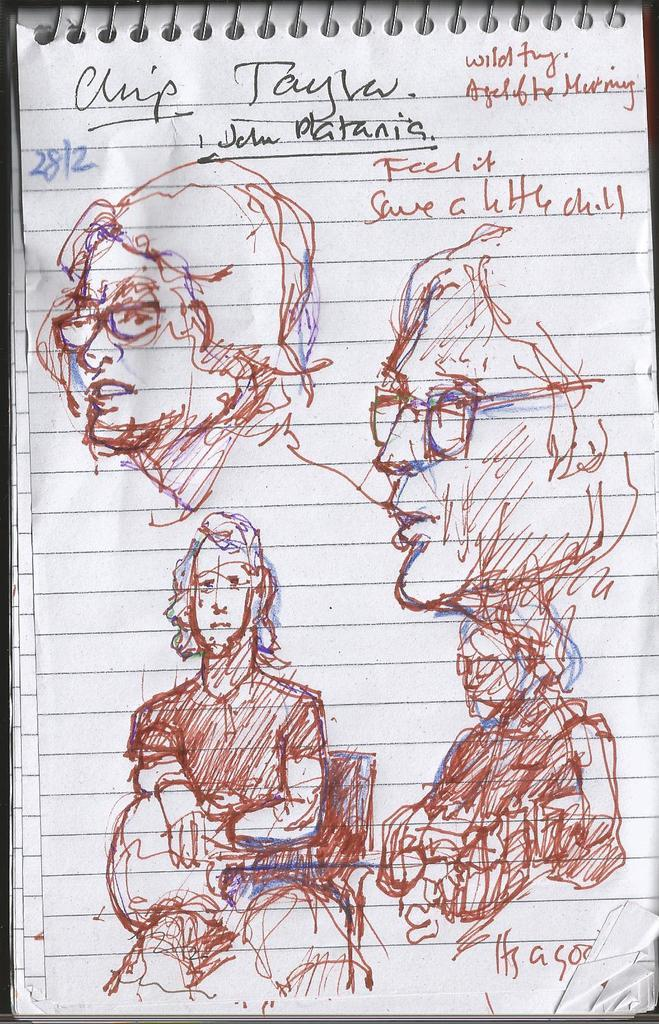What type of book is shown in the image? There is a spiral binding book in the image. What can be found inside the book? The book contains sketches of persons. Is there any writing on the book? Yes, there is handwritten text on the book. What size sheet is used for the sketches in the book? The provided facts do not mention the size of the sheet used for the sketches in the book. 